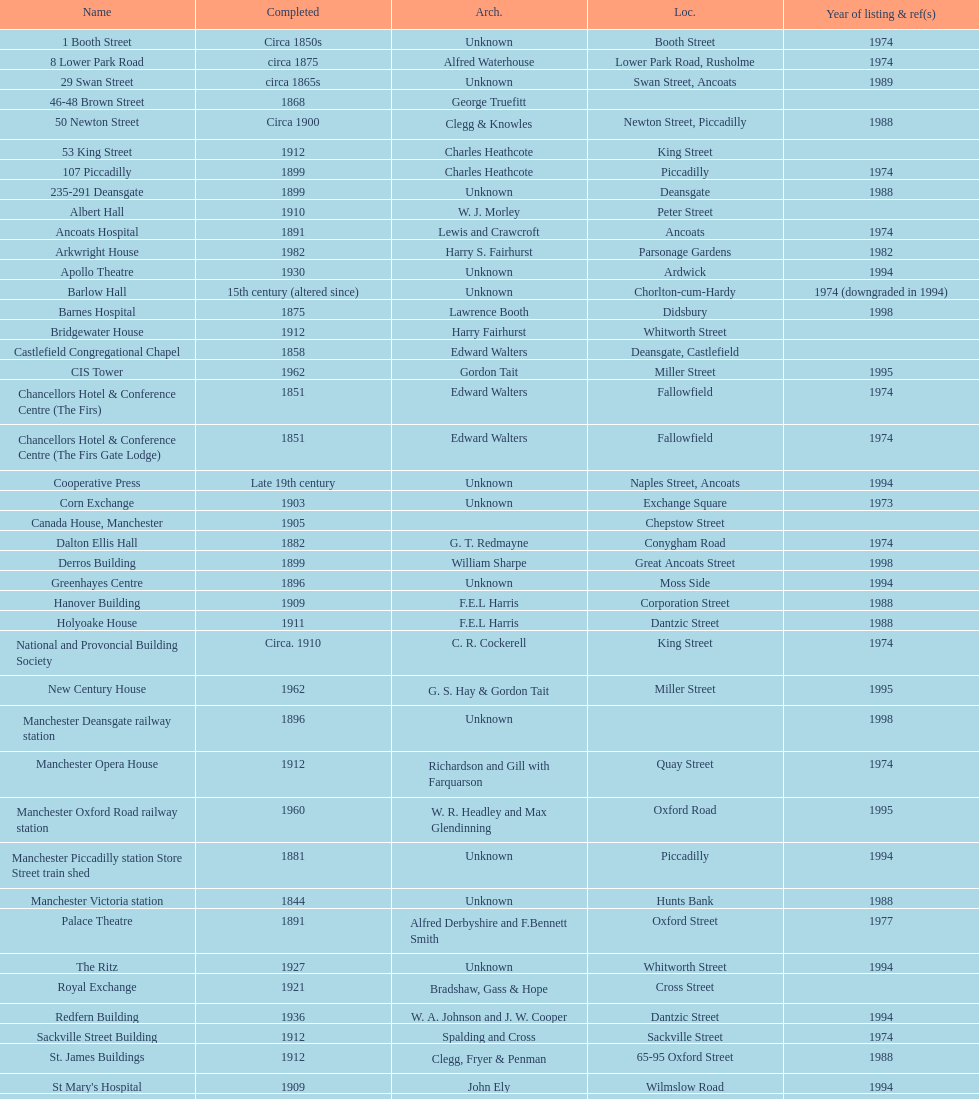What is the street of the only building listed in 1989? Swan Street. Would you mind parsing the complete table? {'header': ['Name', 'Completed', 'Arch.', 'Loc.', 'Year of listing & ref(s)'], 'rows': [['1 Booth Street', 'Circa 1850s', 'Unknown', 'Booth Street', '1974'], ['8 Lower Park Road', 'circa 1875', 'Alfred Waterhouse', 'Lower Park Road, Rusholme', '1974'], ['29 Swan Street', 'circa 1865s', 'Unknown', 'Swan Street, Ancoats', '1989'], ['46-48 Brown Street', '1868', 'George Truefitt', '', ''], ['50 Newton Street', 'Circa 1900', 'Clegg & Knowles', 'Newton Street, Piccadilly', '1988'], ['53 King Street', '1912', 'Charles Heathcote', 'King Street', ''], ['107 Piccadilly', '1899', 'Charles Heathcote', 'Piccadilly', '1974'], ['235-291 Deansgate', '1899', 'Unknown', 'Deansgate', '1988'], ['Albert Hall', '1910', 'W. J. Morley', 'Peter Street', ''], ['Ancoats Hospital', '1891', 'Lewis and Crawcroft', 'Ancoats', '1974'], ['Arkwright House', '1982', 'Harry S. Fairhurst', 'Parsonage Gardens', '1982'], ['Apollo Theatre', '1930', 'Unknown', 'Ardwick', '1994'], ['Barlow Hall', '15th century (altered since)', 'Unknown', 'Chorlton-cum-Hardy', '1974 (downgraded in 1994)'], ['Barnes Hospital', '1875', 'Lawrence Booth', 'Didsbury', '1998'], ['Bridgewater House', '1912', 'Harry Fairhurst', 'Whitworth Street', ''], ['Castlefield Congregational Chapel', '1858', 'Edward Walters', 'Deansgate, Castlefield', ''], ['CIS Tower', '1962', 'Gordon Tait', 'Miller Street', '1995'], ['Chancellors Hotel & Conference Centre (The Firs)', '1851', 'Edward Walters', 'Fallowfield', '1974'], ['Chancellors Hotel & Conference Centre (The Firs Gate Lodge)', '1851', 'Edward Walters', 'Fallowfield', '1974'], ['Cooperative Press', 'Late 19th century', 'Unknown', 'Naples Street, Ancoats', '1994'], ['Corn Exchange', '1903', 'Unknown', 'Exchange Square', '1973'], ['Canada House, Manchester', '1905', '', 'Chepstow Street', ''], ['Dalton Ellis Hall', '1882', 'G. T. Redmayne', 'Conygham Road', '1974'], ['Derros Building', '1899', 'William Sharpe', 'Great Ancoats Street', '1998'], ['Greenhayes Centre', '1896', 'Unknown', 'Moss Side', '1994'], ['Hanover Building', '1909', 'F.E.L Harris', 'Corporation Street', '1988'], ['Holyoake House', '1911', 'F.E.L Harris', 'Dantzic Street', '1988'], ['National and Provoncial Building Society', 'Circa. 1910', 'C. R. Cockerell', 'King Street', '1974'], ['New Century House', '1962', 'G. S. Hay & Gordon Tait', 'Miller Street', '1995'], ['Manchester Deansgate railway station', '1896', 'Unknown', '', '1998'], ['Manchester Opera House', '1912', 'Richardson and Gill with Farquarson', 'Quay Street', '1974'], ['Manchester Oxford Road railway station', '1960', 'W. R. Headley and Max Glendinning', 'Oxford Road', '1995'], ['Manchester Piccadilly station Store Street train shed', '1881', 'Unknown', 'Piccadilly', '1994'], ['Manchester Victoria station', '1844', 'Unknown', 'Hunts Bank', '1988'], ['Palace Theatre', '1891', 'Alfred Derbyshire and F.Bennett Smith', 'Oxford Street', '1977'], ['The Ritz', '1927', 'Unknown', 'Whitworth Street', '1994'], ['Royal Exchange', '1921', 'Bradshaw, Gass & Hope', 'Cross Street', ''], ['Redfern Building', '1936', 'W. A. Johnson and J. W. Cooper', 'Dantzic Street', '1994'], ['Sackville Street Building', '1912', 'Spalding and Cross', 'Sackville Street', '1974'], ['St. James Buildings', '1912', 'Clegg, Fryer & Penman', '65-95 Oxford Street', '1988'], ["St Mary's Hospital", '1909', 'John Ely', 'Wilmslow Road', '1994'], ['Samuel Alexander Building', '1919', 'Percy Scott Worthington', 'Oxford Road', '2010'], ['Ship Canal House', '1927', 'Harry S. Fairhurst', 'King Street', '1982'], ['Smithfield Market Hall', '1857', 'Unknown', 'Swan Street, Ancoats', '1973'], ['Strangeways Gaol Gatehouse', '1868', 'Alfred Waterhouse', 'Sherborne Street', '1974'], ['Strangeways Prison ventilation and watch tower', '1868', 'Alfred Waterhouse', 'Sherborne Street', '1974'], ['Theatre Royal', '1845', 'Irwin and Chester', 'Peter Street', '1974'], ['Toast Rack', '1960', 'L. C. Howitt', 'Fallowfield', '1999'], ['The Old Wellington Inn', 'Mid-16th century', 'Unknown', 'Shambles Square', '1952'], ['Whitworth Park Mansions', 'Circa 1840s', 'Unknown', 'Whitworth Park', '1974']]} 